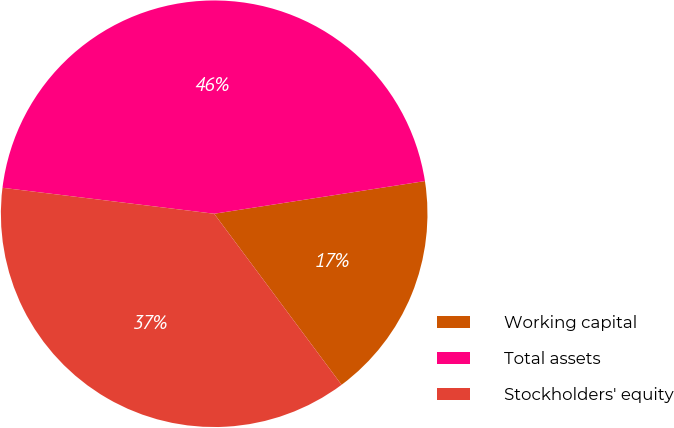Convert chart. <chart><loc_0><loc_0><loc_500><loc_500><pie_chart><fcel>Working capital<fcel>Total assets<fcel>Stockholders' equity<nl><fcel>17.26%<fcel>45.61%<fcel>37.13%<nl></chart> 